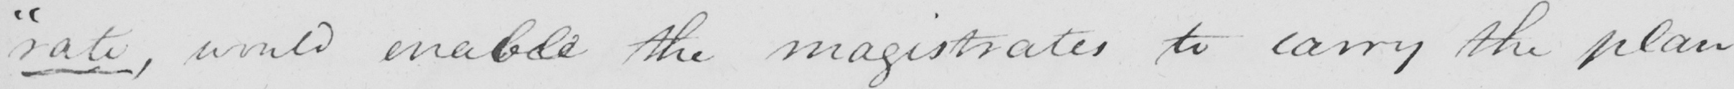What is written in this line of handwriting? -rate , would enable the magistrates to carry the plan 